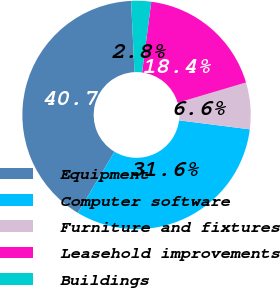Convert chart. <chart><loc_0><loc_0><loc_500><loc_500><pie_chart><fcel>Equipment<fcel>Computer software<fcel>Furniture and fixtures<fcel>Leasehold improvements<fcel>Buildings<nl><fcel>40.65%<fcel>31.58%<fcel>6.6%<fcel>18.35%<fcel>2.82%<nl></chart> 